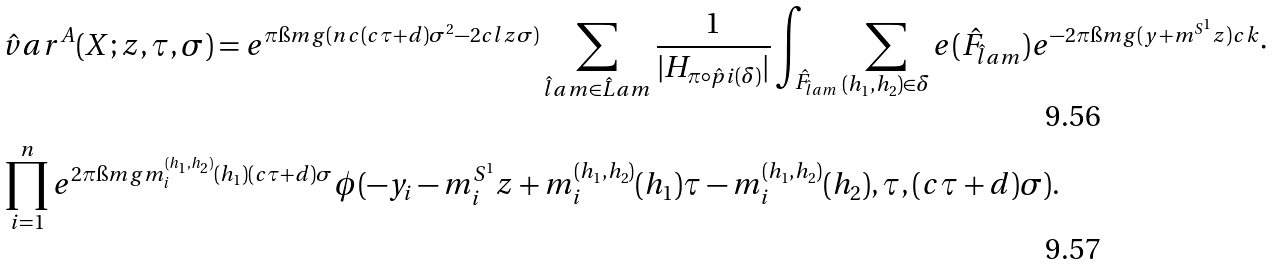<formula> <loc_0><loc_0><loc_500><loc_500>& \hat { v } a r ^ { A } ( X ; z , \tau , \sigma ) = e ^ { \pi \i m g ( n c ( c \tau + d ) \sigma ^ { 2 } - 2 c l z \sigma ) } \sum _ { \hat { l } a m \in \hat { L } a m } \frac { 1 } { | H _ { \pi \circ \hat { p } i ( \delta ) } | } \int _ { \hat { F } _ { \hat { l } a m } } \sum _ { ( h _ { 1 } , h _ { 2 } ) \in \delta } e ( \hat { F } _ { \hat { l } a m } ) e ^ { - 2 \pi \i m g ( y + m ^ { S ^ { 1 } } z ) c k } \cdot \\ & \prod _ { i = 1 } ^ { n } e ^ { 2 \pi \i m g m _ { i } ^ { ( h _ { 1 } , h _ { 2 } ) } ( h _ { 1 } ) ( c \tau + d ) \sigma } \phi ( - y _ { i } - m _ { i } ^ { S ^ { 1 } } z + m _ { i } ^ { ( h _ { 1 } , h _ { 2 } ) } ( h _ { 1 } ) \tau - m _ { i } ^ { ( h _ { 1 } , h _ { 2 } ) } ( h _ { 2 } ) , \tau , ( c \tau + d ) \sigma ) .</formula> 